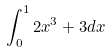<formula> <loc_0><loc_0><loc_500><loc_500>\int _ { 0 } ^ { 1 } 2 x ^ { 3 } + 3 d x</formula> 